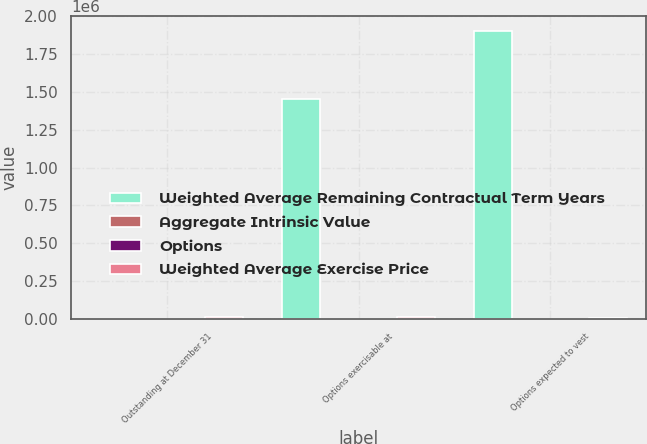Convert chart. <chart><loc_0><loc_0><loc_500><loc_500><stacked_bar_chart><ecel><fcel>Outstanding at December 31<fcel>Options exercisable at<fcel>Options expected to vest<nl><fcel>Weighted Average Remaining Contractual Term Years<fcel>35.73<fcel>1.451e+06<fcel>1.90642e+06<nl><fcel>Aggregate Intrinsic Value<fcel>31.79<fcel>26.38<fcel>35.73<nl><fcel>Options<fcel>6.9<fcel>4.42<fcel>8.68<nl><fcel>Weighted Average Exercise Price<fcel>13484<fcel>11422<fcel>1987<nl></chart> 